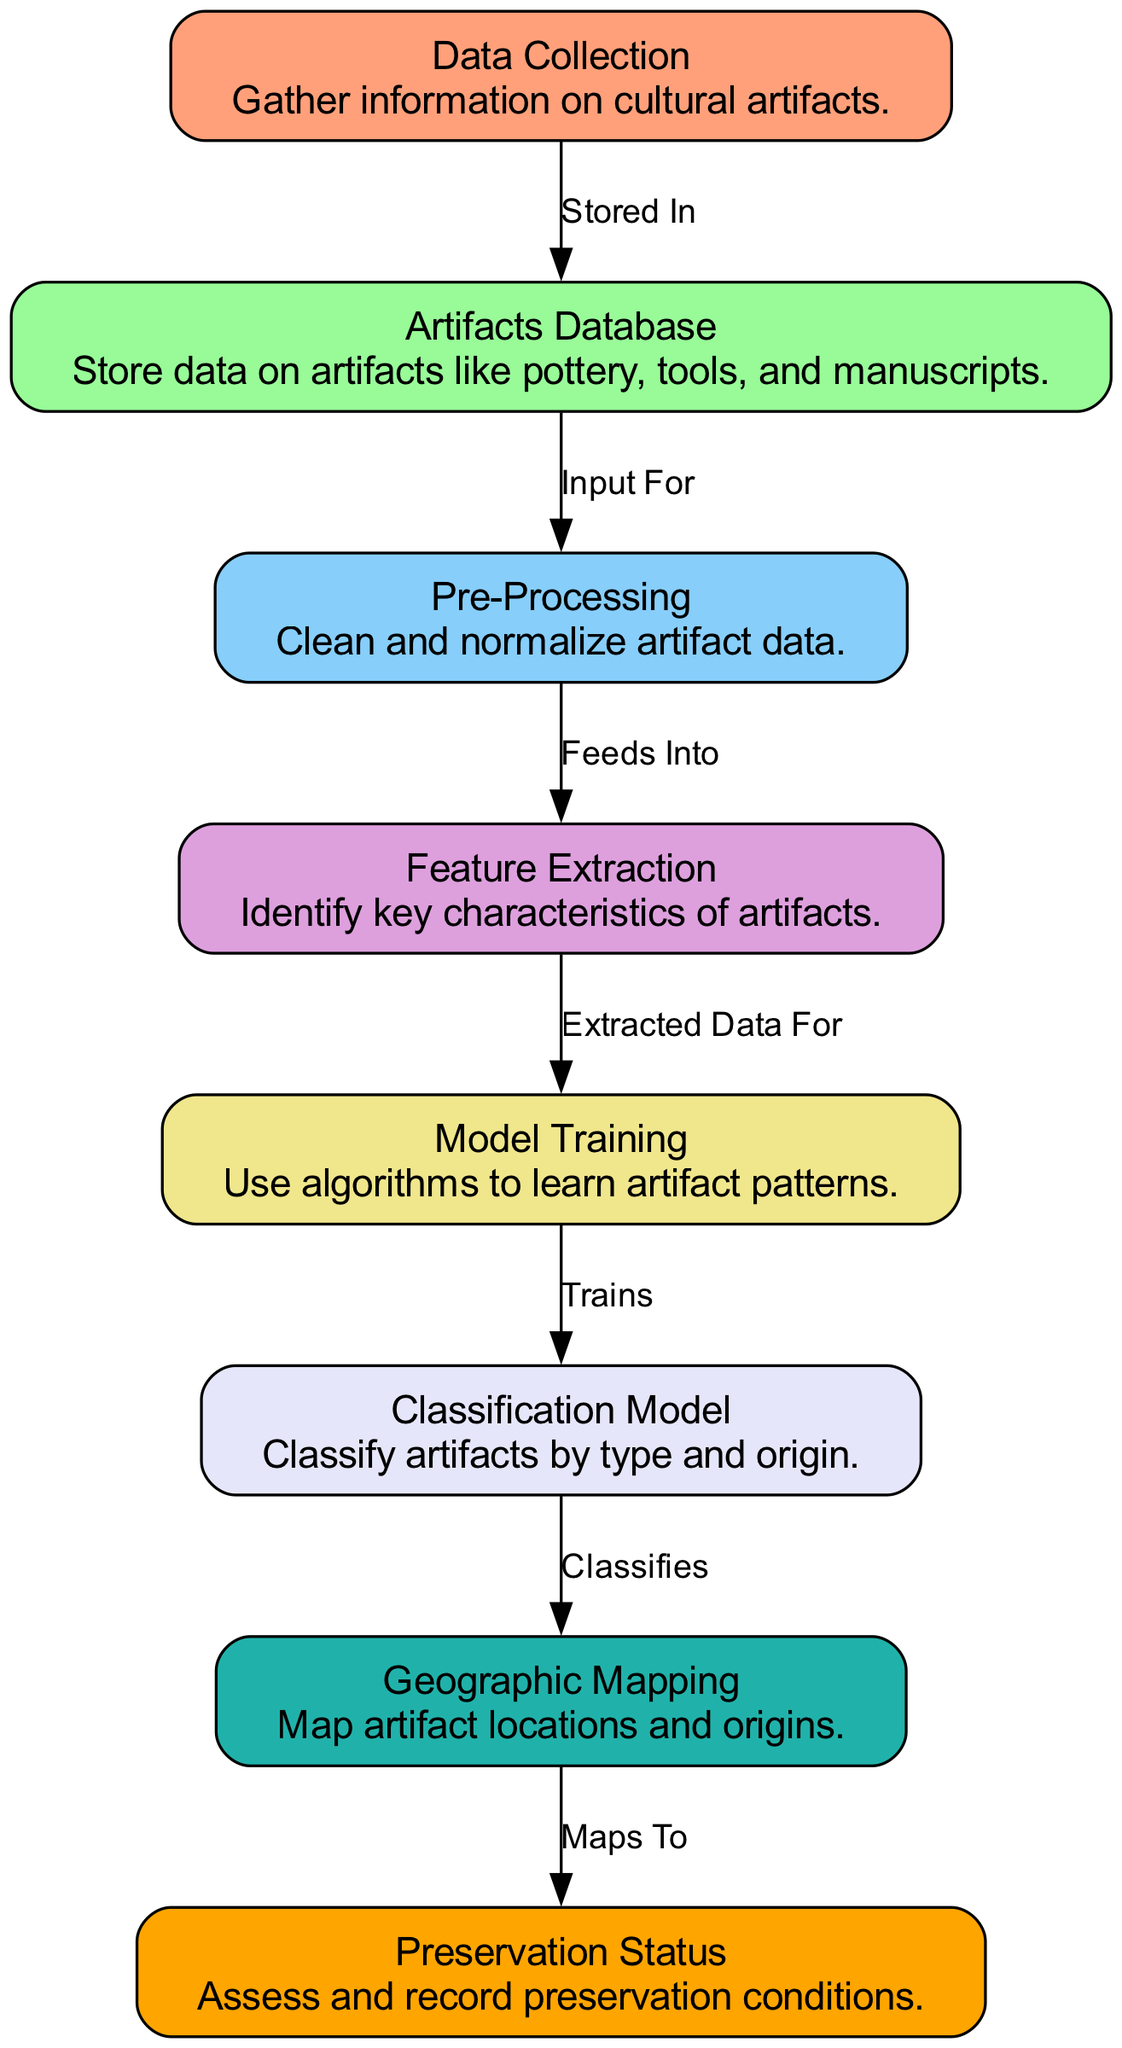What is the first step in the process? The first step, represented by the node "Data Collection," involves gathering information on cultural artifacts. This is evident as it is the starting point of the flow in the diagram.
Answer: Data Collection How many nodes are present in the diagram? By counting the distinct nodes listed, there are a total of eight nodes in the diagram, each representing a different step or component in the artifact preservation model.
Answer: 8 What does the "Model Training" node receive as its input? The "Model Training" node receives input from the "Feature Extraction" node, which prepares the data extracted from the artifacts for training machine learning algorithms. This relationship is indicated by the directed edge between these nodes.
Answer: Feature Extraction Which node is responsible for evaluating preservation conditions? The node responsible for recording preservation conditions is "Preservation Status." This node appears at the end of the process and focuses on assessing the condition of the artifacts after they have been classified and mapped.
Answer: Preservation Status What type of artifacts does the "Classification Model" specifically categorize? The "Classification Model" categorizes artifacts by type and origin, as explicitly stated in its details. This classification helps in understanding the diversity of artifacts and their historical contexts.
Answer: Type and origin Which node connects the "Classification Model" and "GeoMapping"? The "GeoMapping" node is connected to the "Classification Model" node, indicating that it classifies artifacts and maps their geographical locations based on the classification results. This connection highlights the flow from classification to geographic representation.
Answer: GeoMapping What is the purpose of the "Feature Extraction" node in this diagram? The purpose of the "Feature Extraction" node is to identify key characteristics of artifacts, which involves processing the cleaned data from the "Pre-Processing" node to extract features useful for model training. It acts as a bridge between data processing and model training.
Answer: Identify key characteristics What does the directed edge from "GeoMapping" to "Preservation Status" signify? The directed edge from "GeoMapping" to "Preservation Status" signifies that the geographic mapping data feeds into the assessment and recording of preservation conditions, illustrating how the location context of artifacts plays a role in their preservation.
Answer: Maps To 